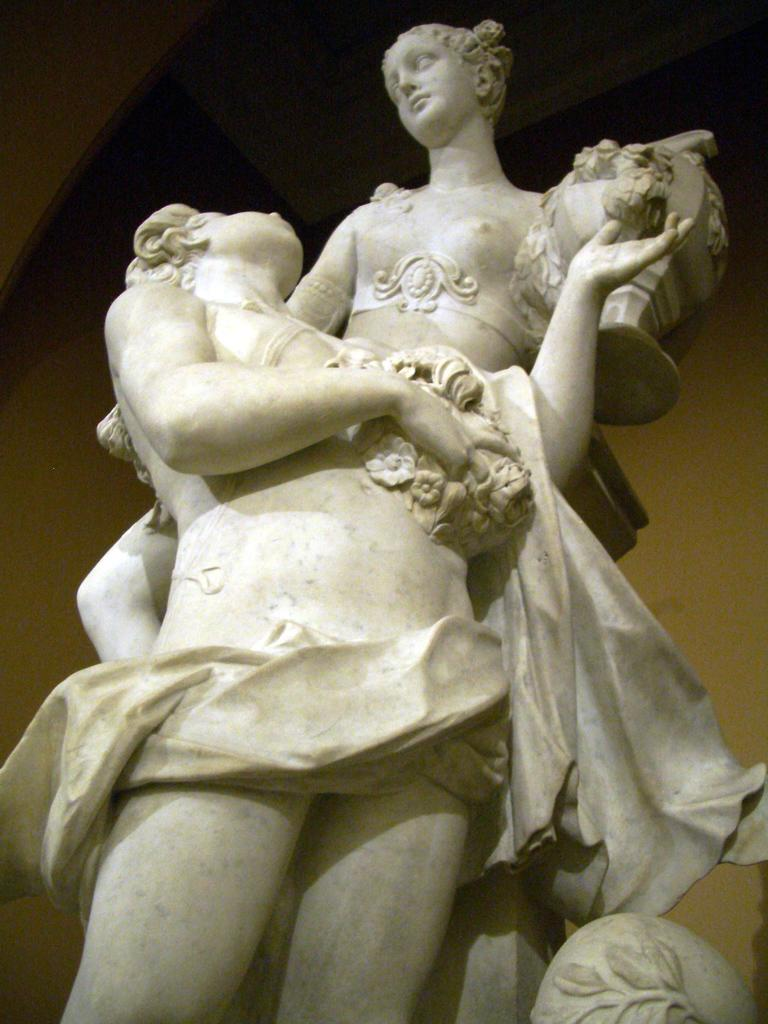What is the main subject in the center of the image? There is a statue in the center of the image. What can be seen in the background of the image? There is a wall in the background of the image. What type of sugar is being used to support the statue in the image? There is no sugar present in the image, and the statue is not supported by any sugar. 